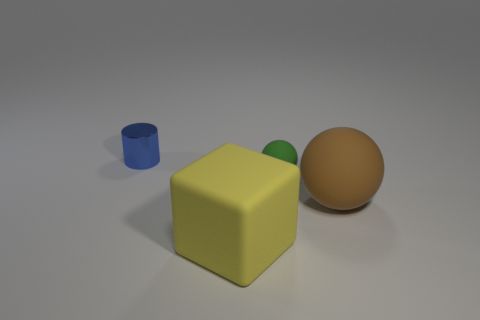What is the shape of the big brown object that is made of the same material as the green sphere?
Keep it short and to the point. Sphere. Is there any other thing of the same color as the cylinder?
Offer a very short reply. No. There is a object that is to the right of the matte thing that is behind the big matte ball; how many blue metallic things are in front of it?
Keep it short and to the point. 0. What number of blue things are big rubber cubes or tiny shiny things?
Your answer should be compact. 1. There is a green rubber ball; is its size the same as the thing that is behind the tiny ball?
Ensure brevity in your answer.  Yes. There is a tiny object that is the same shape as the large brown object; what material is it?
Provide a short and direct response. Rubber. What number of other things are the same size as the cube?
Your answer should be compact. 1. What is the shape of the large matte object that is right of the big matte thing left of the matte sphere behind the brown thing?
Offer a very short reply. Sphere. What shape is the rubber object that is both left of the brown matte thing and behind the yellow thing?
Provide a short and direct response. Sphere. What number of objects are small blue cylinders or things to the right of the blue object?
Give a very brief answer. 4. 